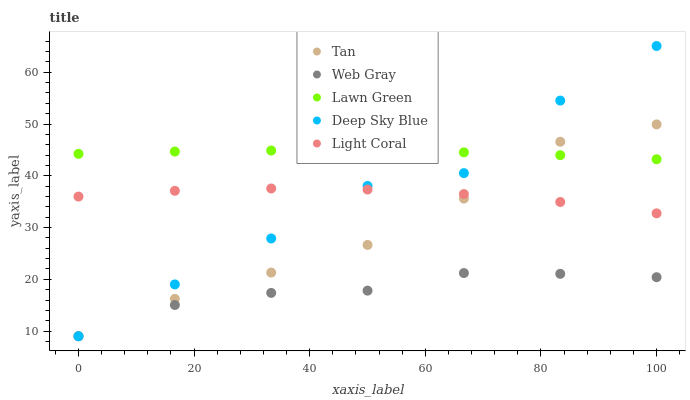Does Web Gray have the minimum area under the curve?
Answer yes or no. Yes. Does Lawn Green have the maximum area under the curve?
Answer yes or no. Yes. Does Tan have the minimum area under the curve?
Answer yes or no. No. Does Tan have the maximum area under the curve?
Answer yes or no. No. Is Lawn Green the smoothest?
Answer yes or no. Yes. Is Deep Sky Blue the roughest?
Answer yes or no. Yes. Is Tan the smoothest?
Answer yes or no. No. Is Tan the roughest?
Answer yes or no. No. Does Tan have the lowest value?
Answer yes or no. Yes. Does Lawn Green have the lowest value?
Answer yes or no. No. Does Deep Sky Blue have the highest value?
Answer yes or no. Yes. Does Lawn Green have the highest value?
Answer yes or no. No. Is Web Gray less than Lawn Green?
Answer yes or no. Yes. Is Lawn Green greater than Web Gray?
Answer yes or no. Yes. Does Lawn Green intersect Deep Sky Blue?
Answer yes or no. Yes. Is Lawn Green less than Deep Sky Blue?
Answer yes or no. No. Is Lawn Green greater than Deep Sky Blue?
Answer yes or no. No. Does Web Gray intersect Lawn Green?
Answer yes or no. No. 